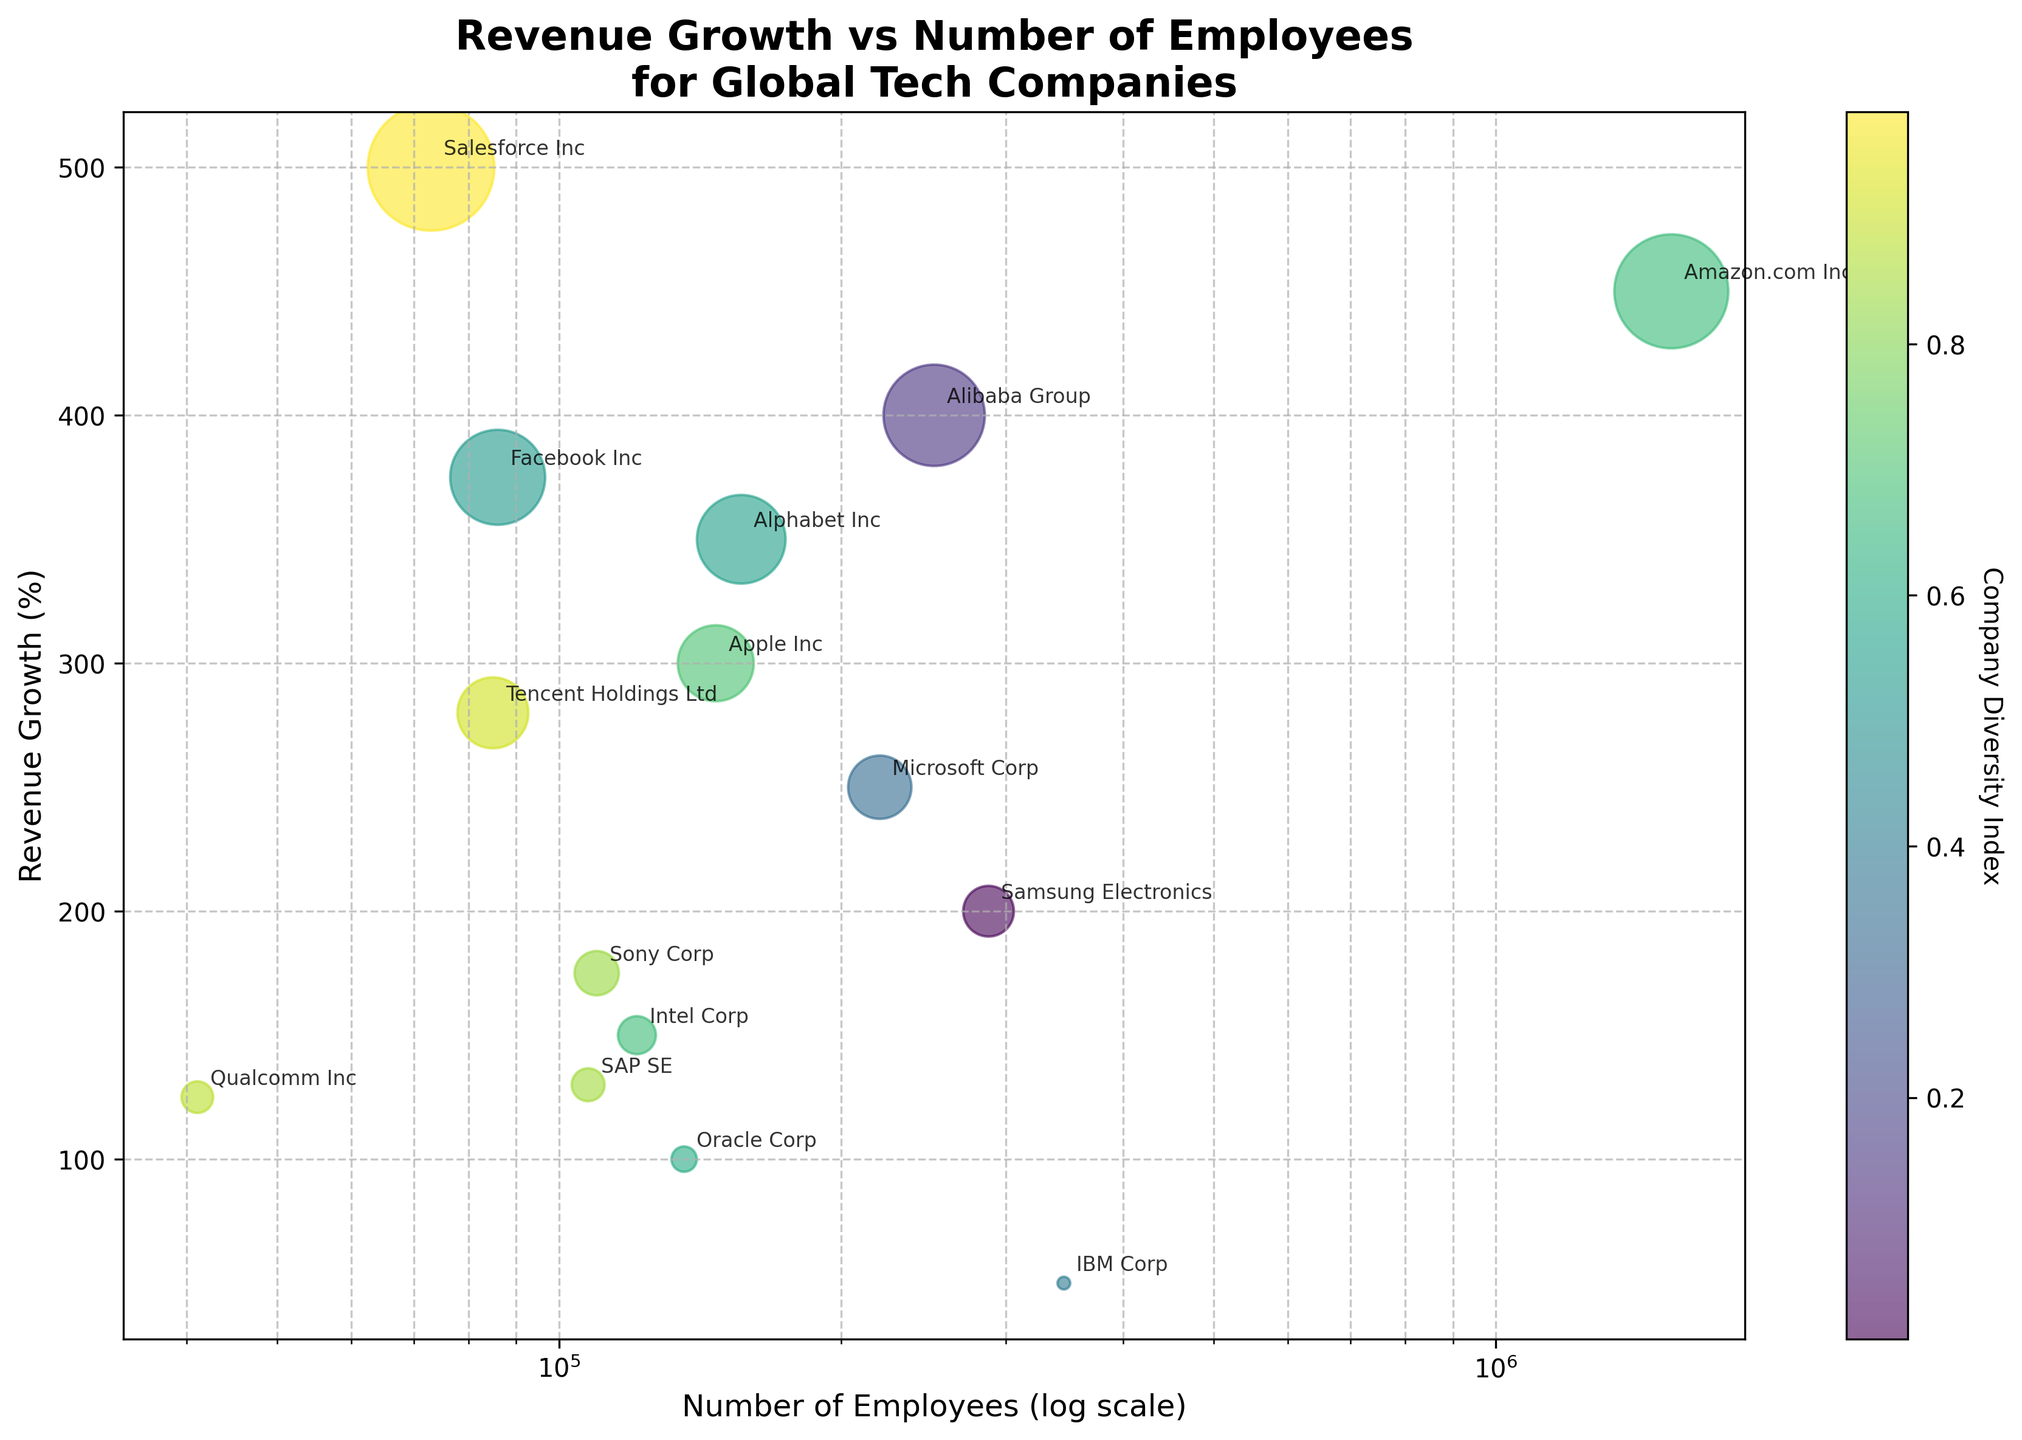What is the title of the plot? The figure has a clearly displayed title located at the top, which summarizes the content of the plot. It reads "Revenue Growth vs Number of Employees for Global Tech Companies."
Answer: Revenue Growth vs Number of Employees for Global Tech Companies How many companies are plotted in the scatter plot? By counting the distinct points plotted on the scatter plot, which are individually annotated with company names, we can determine the total number. There are 15 distinct companies shown in the plot.
Answer: 15 Which company has the highest revenue growth? By observing the y-axis (Revenue Growth (%)), we can see which point is positioned highest. Salesforce Inc, located near the top of the plot, has the highest revenue growth.
Answer: Salesforce Inc How does the revenue growth of Apple Inc compare to that of Intel Corp? By locating both Apple Inc and Intel Corp on the plot, we can compare their positions on the y-axis. Apple Inc has a revenue growth of 300%, whereas Intel Corp has a revenue growth of 150%. Therefore, Apple's growth is higher.
Answer: Apple Inc has higher revenue growth What is the range of the number of employees in the companies displayed? By checking the x-axis, which is on a logarithmic scale, the minimum number of employees is from Qualcomm Inc (around 41,100) and the maximum is from Amazon.com Inc (around 1,540,000).
Answer: 41,100 to 1,540,000 Which company has the lowest revenue growth, and what is that value? By identifying the lowest point on the y-axis, we find that IBM Corp is positioned lowest, indicating it has the lowest revenue growth. The corresponding y-value shows IBM Corp has a revenue growth of 50%.
Answer: IBM Corp, 50% What is the average revenue growth of the top three companies by number of employees? First, identify the three companies with the highest number of employees: Amazon.com Inc (1,540,000), IBM Corp (345,900), and Samsung Electronics (287,439). Their revenue growth values are 450%, 50%, and 200%, respectively. The average is calculated as (450 + 50 + 200) / 3 = 700 / 3 ≈ 233.33%.
Answer: 233.33% Which company has the most balanced (middle value) number of employees, and what is that number? To find the company with the median number of employees, sort the companies by employees and pick the middle one. The sorted list gives Tencent Holdings Ltd (85,000) as the company with the median number of employees.
Answer: Tencent Holdings Ltd, 85,000 Are there any clear outliers in the plot, and if so, which companies are they? An outlier can be identified by significantly deviating from the general trend. Amazon.com Inc with 1,540,000 employees is an outlier on the x-axis due to its much higher number of employees compared to other companies.
Answer: Amazon.com Inc 